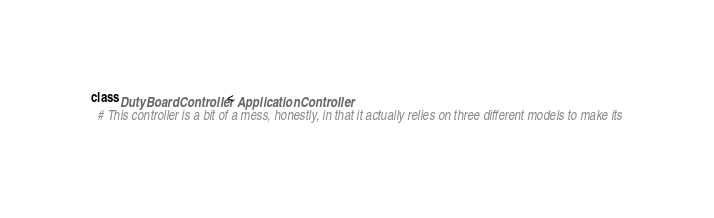<code> <loc_0><loc_0><loc_500><loc_500><_Ruby_>class DutyBoardController < ApplicationController
  # This controller is a bit of a mess, honestly, in that it actually relies on three different models to make its</code> 